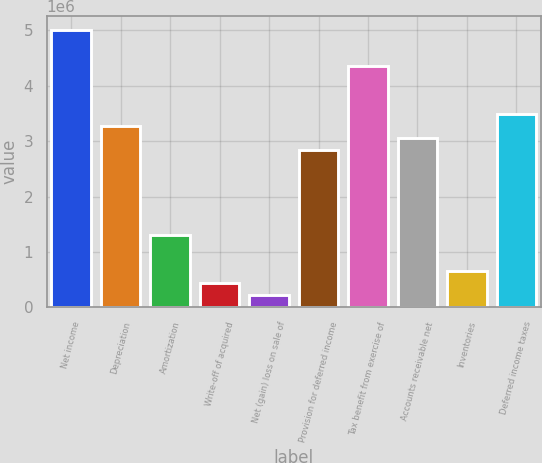<chart> <loc_0><loc_0><loc_500><loc_500><bar_chart><fcel>Net income<fcel>Depreciation<fcel>Amortization<fcel>Write-off of acquired<fcel>Net (gain) loss on sale of<fcel>Provision for deferred income<fcel>Tax benefit from exercise of<fcel>Accounts receivable net<fcel>Inventories<fcel>Deferred income taxes<nl><fcel>5.0099e+06<fcel>3.26949e+06<fcel>1.31154e+06<fcel>441335<fcel>223785<fcel>2.83439e+06<fcel>4.35725e+06<fcel>3.05194e+06<fcel>658886<fcel>3.48705e+06<nl></chart> 